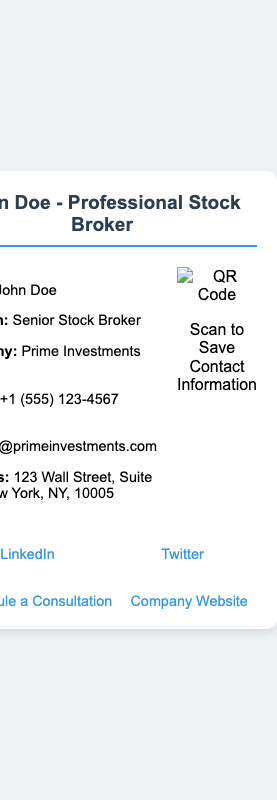What is the name on the business card? The name on the business card is clearly displayed at the top.
Answer: John Doe What is John Doe's position? The position is mentioned right after the name section.
Answer: Senior Stock Broker What is the phone number listed? The phone number can be found in the contact information section.
Answer: +1 (555) 123-4567 Where is John Doe's office located? The address is specified in the contact section of the card.
Answer: 123 Wall Street, Suite 456, New York, NY, 10005 What company does John Doe work for? The company name is provided in the contact information.
Answer: Prime Investments Inc What can you scan the QR code for? The purpose of the QR code is specified below the image.
Answer: Save Contact Information What social media platform is linked on the card? The options provided in the social media section include various platforms.
Answer: LinkedIn What is one of the additional resources available? The additional resources section mentions services offered.
Answer: Schedule a Consultation 